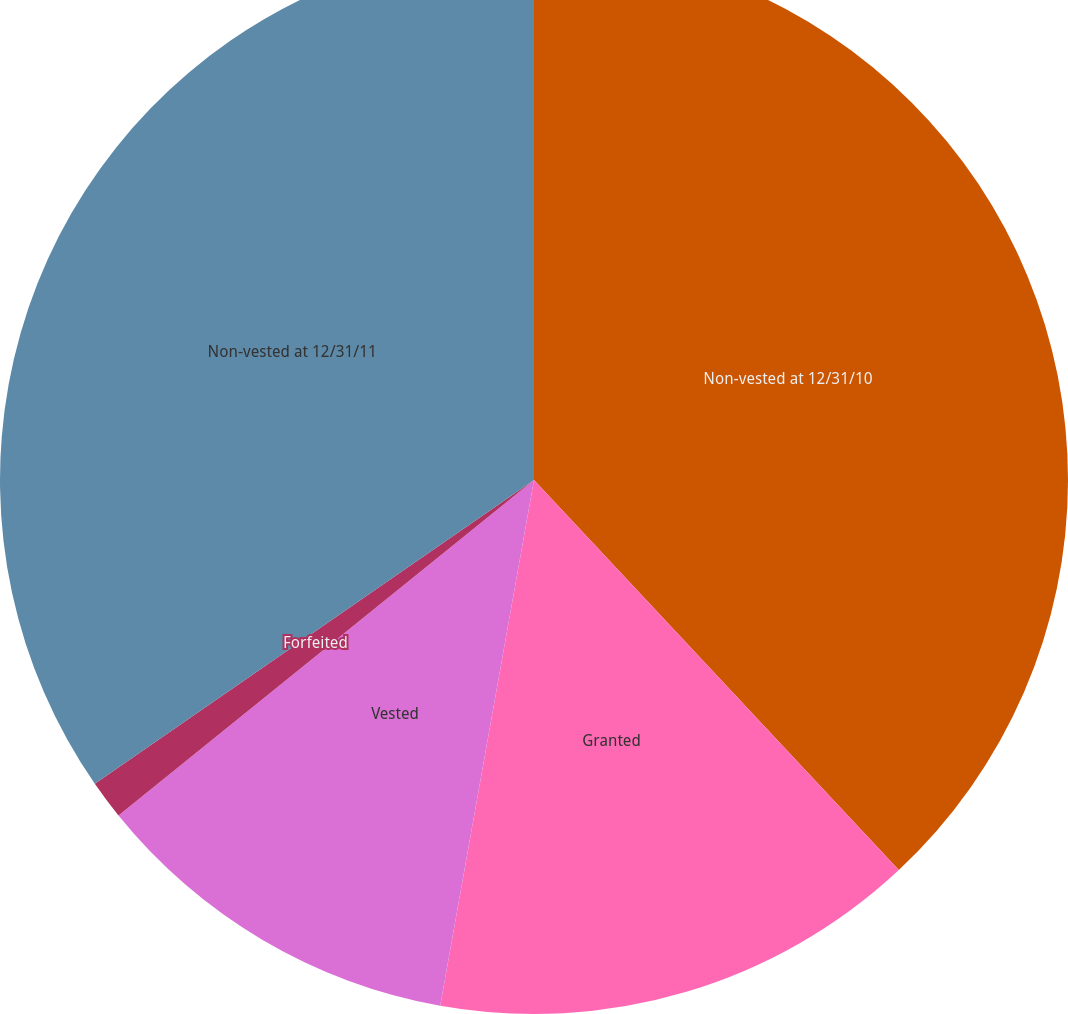<chart> <loc_0><loc_0><loc_500><loc_500><pie_chart><fcel>Non-vested at 12/31/10<fcel>Granted<fcel>Vested<fcel>Forfeited<fcel>Non-vested at 12/31/11<nl><fcel>38.03%<fcel>14.78%<fcel>11.38%<fcel>1.18%<fcel>34.63%<nl></chart> 